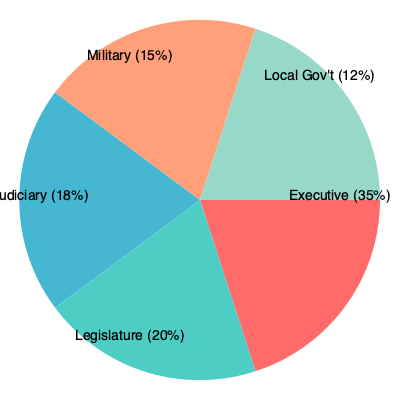Based on the pie chart depicting the distribution of power among different political institutions in a post-conflict state, which institution holds the most influence, and what potential challenges might this pose for the process of democratization? To answer this question, we need to analyze the pie chart and consider the implications of power distribution in a post-conflict state:

1. Identify the institution with the most influence:
   - Executive: 35%
   - Legislature: 20%
   - Judiciary: 18%
   - Military: 15%
   - Local Government: 12%

   The Executive branch holds the largest share at 35%, indicating it has the most influence.

2. Consider the challenges this power distribution poses for democratization:

   a) Executive dominance:
      - The executive's disproportionate power (35%) compared to other institutions may lead to an imbalance in the system of checks and balances.
      - This could result in the consolidation of power in the hands of a single individual or small group, potentially leading to authoritarian tendencies.

   b) Weak legislature:
      - The legislature's relatively small share (20%) may limit its ability to effectively represent diverse interests and check executive power.
      - This imbalance could hinder the development of robust democratic processes and policy-making.

   c) Judiciary independence:
      - With only 18% of power, the judiciary may struggle to maintain its independence and effectively uphold the rule of law.
      - This could compromise the protection of civil liberties and the adjudication of political disputes.

   d) Military influence:
      - The military's significant share (15%) in a post-conflict state may indicate ongoing security concerns.
      - However, it also poses a risk of military interference in civilian affairs, potentially undermining democratic processes.

   e) Limited local governance:
      - The relatively small share (12%) allocated to local government may hinder decentralization efforts and grass-roots democratic participation.
      - This could lead to a concentration of power at the national level, potentially alienating local communities and exacerbating regional tensions.

3. Implications for democratization:
   - The uneven distribution of power, particularly the executive's dominance, may slow down or complicate the transition to a fully functioning democracy.
   - Efforts to strengthen democratic institutions and promote a more balanced distribution of power will be crucial for successful democratization.
Answer: Executive dominance (35%) poses challenges for democratization by potentially undermining checks and balances, weakening other institutions, and concentrating power, which may hinder the development of robust democratic processes and institutions. 